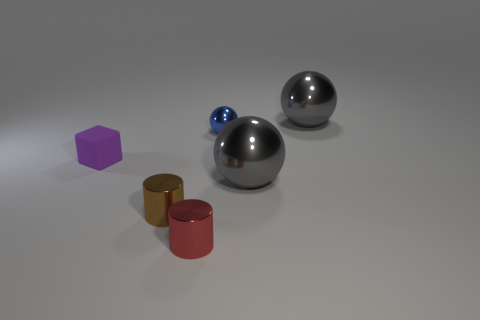Add 3 small green metallic cubes. How many objects exist? 9 Subtract all blocks. How many objects are left? 5 Add 5 gray shiny things. How many gray shiny things exist? 7 Subtract 0 purple spheres. How many objects are left? 6 Subtract all tiny brown metallic cylinders. Subtract all matte things. How many objects are left? 4 Add 3 brown metal cylinders. How many brown metal cylinders are left? 4 